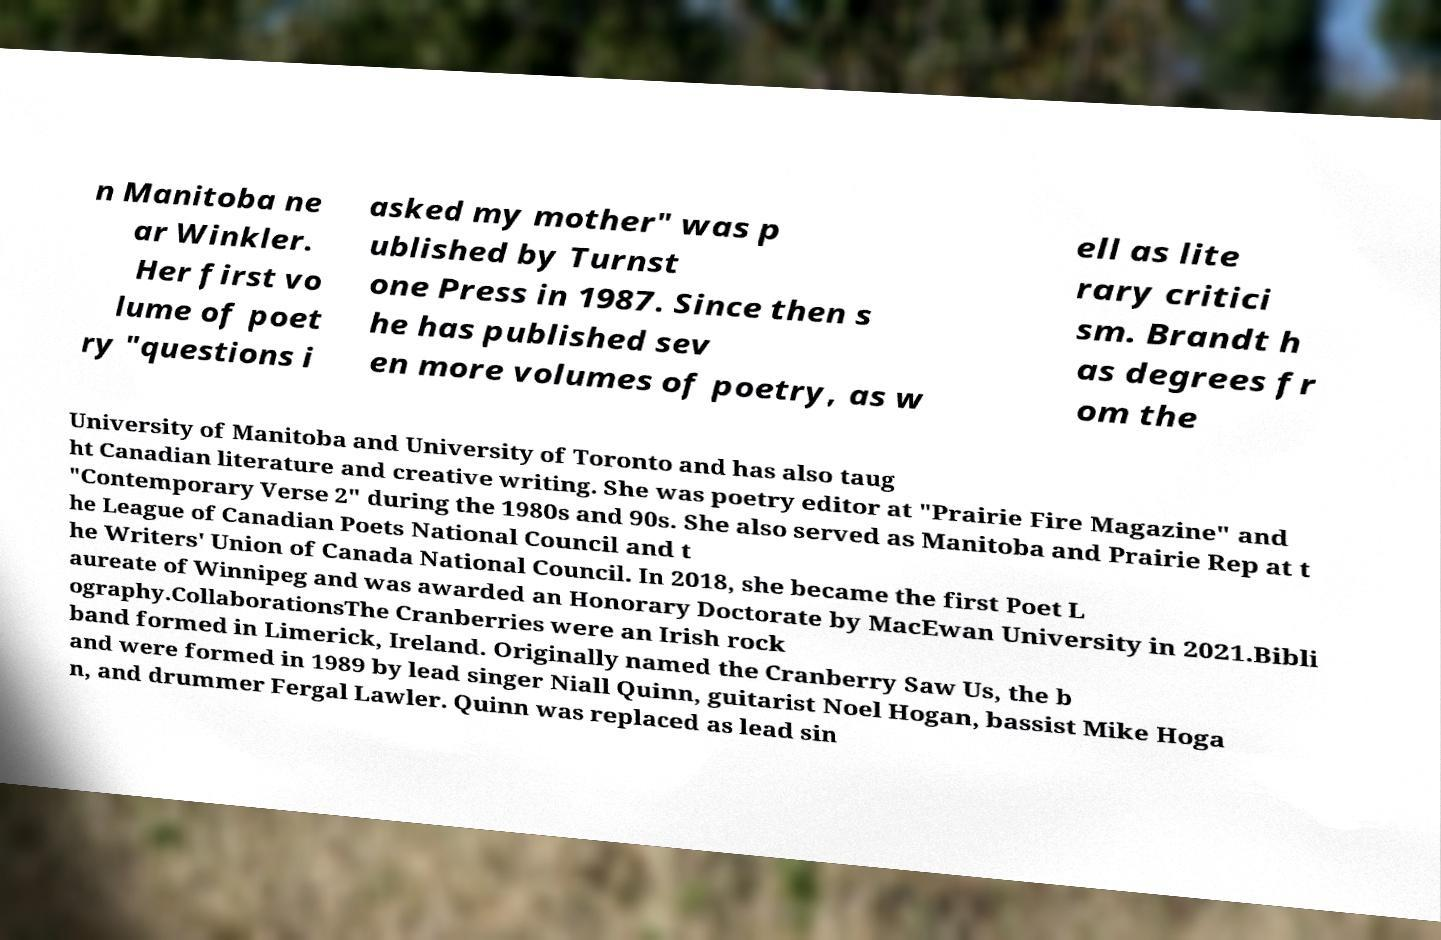Could you extract and type out the text from this image? n Manitoba ne ar Winkler. Her first vo lume of poet ry "questions i asked my mother" was p ublished by Turnst one Press in 1987. Since then s he has published sev en more volumes of poetry, as w ell as lite rary critici sm. Brandt h as degrees fr om the University of Manitoba and University of Toronto and has also taug ht Canadian literature and creative writing. She was poetry editor at "Prairie Fire Magazine" and "Contemporary Verse 2" during the 1980s and 90s. She also served as Manitoba and Prairie Rep at t he League of Canadian Poets National Council and t he Writers' Union of Canada National Council. In 2018, she became the first Poet L aureate of Winnipeg and was awarded an Honorary Doctorate by MacEwan University in 2021.Bibli ography.CollaborationsThe Cranberries were an Irish rock band formed in Limerick, Ireland. Originally named the Cranberry Saw Us, the b and were formed in 1989 by lead singer Niall Quinn, guitarist Noel Hogan, bassist Mike Hoga n, and drummer Fergal Lawler. Quinn was replaced as lead sin 